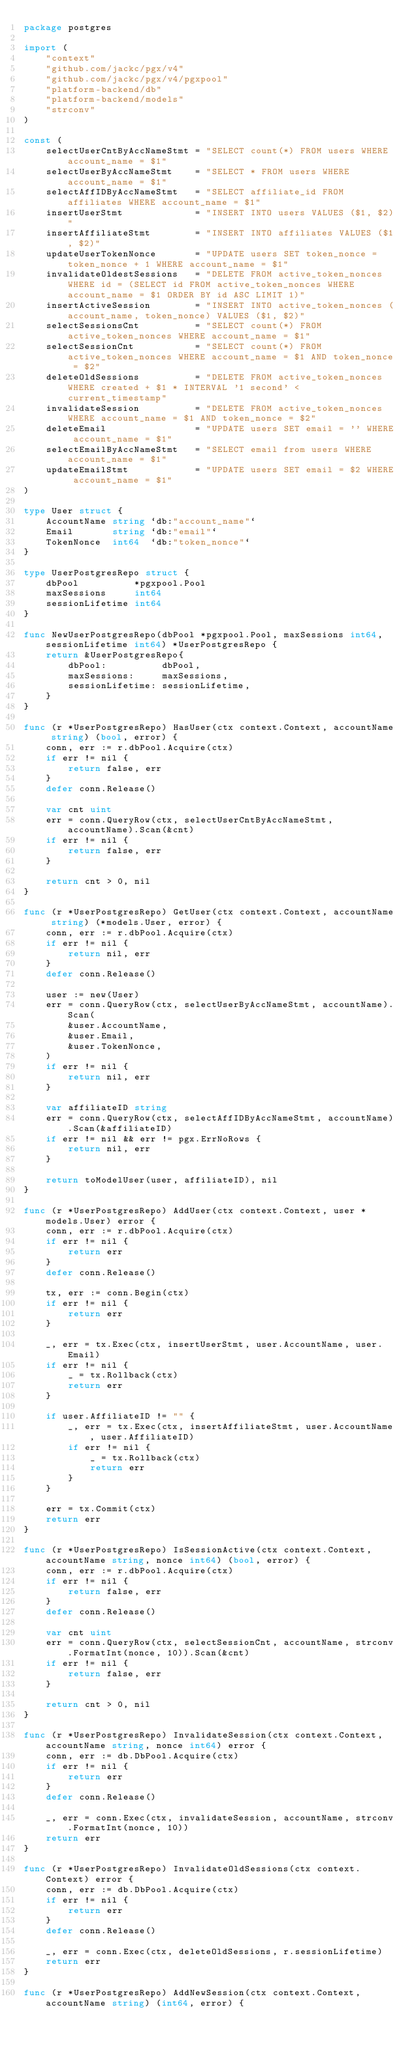Convert code to text. <code><loc_0><loc_0><loc_500><loc_500><_Go_>package postgres

import (
	"context"
	"github.com/jackc/pgx/v4"
	"github.com/jackc/pgx/v4/pgxpool"
	"platform-backend/db"
	"platform-backend/models"
	"strconv"
)

const (
	selectUserCntByAccNameStmt = "SELECT count(*) FROM users WHERE account_name = $1"
	selectUserByAccNameStmt    = "SELECT * FROM users WHERE account_name = $1"
	selectAffIDByAccNameStmt   = "SELECT affiliate_id FROM affiliates WHERE account_name = $1"
	insertUserStmt             = "INSERT INTO users VALUES ($1, $2)"
	insertAffiliateStmt        = "INSERT INTO affiliates VALUES ($1, $2)"
	updateUserTokenNonce       = "UPDATE users SET token_nonce = token_nonce + 1 WHERE account_name = $1"
	invalidateOldestSessions   = "DELETE FROM active_token_nonces WHERE id = (SELECT id FROM active_token_nonces WHERE account_name = $1 ORDER BY id ASC LIMIT 1)"
	insertActiveSession        = "INSERT INTO active_token_nonces (account_name, token_nonce) VALUES ($1, $2)"
	selectSessionsCnt          = "SELECT count(*) FROM active_token_nonces WHERE account_name = $1"
	selectSessionCnt           = "SELECT count(*) FROM active_token_nonces WHERE account_name = $1 AND token_nonce = $2"
	deleteOldSessions          = "DELETE FROM active_token_nonces WHERE created + $1 * INTERVAL '1 second' < current_timestamp"
	invalidateSession          = "DELETE FROM active_token_nonces WHERE account_name = $1 AND token_nonce = $2"
	deleteEmail                = "UPDATE users SET email = '' WHERE account_name = $1"
	selectEmailByAccNameStmt   = "SELECT email from users WHERE account_name = $1"
	updateEmailStmt            = "UPDATE users SET email = $2 WHERE account_name = $1"
)

type User struct {
	AccountName string `db:"account_name"`
	Email       string `db:"email"`
	TokenNonce  int64  `db:"token_nonce"`
}

type UserPostgresRepo struct {
	dbPool          *pgxpool.Pool
	maxSessions     int64
	sessionLifetime int64
}

func NewUserPostgresRepo(dbPool *pgxpool.Pool, maxSessions int64, sessionLifetime int64) *UserPostgresRepo {
	return &UserPostgresRepo{
		dbPool:          dbPool,
		maxSessions:     maxSessions,
		sessionLifetime: sessionLifetime,
	}
}

func (r *UserPostgresRepo) HasUser(ctx context.Context, accountName string) (bool, error) {
	conn, err := r.dbPool.Acquire(ctx)
	if err != nil {
		return false, err
	}
	defer conn.Release()

	var cnt uint
	err = conn.QueryRow(ctx, selectUserCntByAccNameStmt, accountName).Scan(&cnt)
	if err != nil {
		return false, err
	}

	return cnt > 0, nil
}

func (r *UserPostgresRepo) GetUser(ctx context.Context, accountName string) (*models.User, error) {
	conn, err := r.dbPool.Acquire(ctx)
	if err != nil {
		return nil, err
	}
	defer conn.Release()

	user := new(User)
	err = conn.QueryRow(ctx, selectUserByAccNameStmt, accountName).Scan(
		&user.AccountName,
		&user.Email,
		&user.TokenNonce,
	)
	if err != nil {
		return nil, err
	}

	var affiliateID string
	err = conn.QueryRow(ctx, selectAffIDByAccNameStmt, accountName).Scan(&affiliateID)
	if err != nil && err != pgx.ErrNoRows {
		return nil, err
	}

	return toModelUser(user, affiliateID), nil
}

func (r *UserPostgresRepo) AddUser(ctx context.Context, user *models.User) error {
	conn, err := r.dbPool.Acquire(ctx)
	if err != nil {
		return err
	}
	defer conn.Release()

	tx, err := conn.Begin(ctx)
	if err != nil {
		return err
	}

	_, err = tx.Exec(ctx, insertUserStmt, user.AccountName, user.Email)
	if err != nil {
		_ = tx.Rollback(ctx)
		return err
	}

	if user.AffiliateID != "" {
		_, err = tx.Exec(ctx, insertAffiliateStmt, user.AccountName, user.AffiliateID)
		if err != nil {
			_ = tx.Rollback(ctx)
			return err
		}
	}

	err = tx.Commit(ctx)
	return err
}

func (r *UserPostgresRepo) IsSessionActive(ctx context.Context, accountName string, nonce int64) (bool, error) {
	conn, err := r.dbPool.Acquire(ctx)
	if err != nil {
		return false, err
	}
	defer conn.Release()

	var cnt uint
	err = conn.QueryRow(ctx, selectSessionCnt, accountName, strconv.FormatInt(nonce, 10)).Scan(&cnt)
	if err != nil {
		return false, err
	}

	return cnt > 0, nil
}

func (r *UserPostgresRepo) InvalidateSession(ctx context.Context, accountName string, nonce int64) error {
	conn, err := db.DbPool.Acquire(ctx)
	if err != nil {
		return err
	}
	defer conn.Release()

	_, err = conn.Exec(ctx, invalidateSession, accountName, strconv.FormatInt(nonce, 10))
	return err
}

func (r *UserPostgresRepo) InvalidateOldSessions(ctx context.Context) error {
	conn, err := db.DbPool.Acquire(ctx)
	if err != nil {
		return err
	}
	defer conn.Release()

	_, err = conn.Exec(ctx, deleteOldSessions, r.sessionLifetime)
	return err
}

func (r *UserPostgresRepo) AddNewSession(ctx context.Context, accountName string) (int64, error) {</code> 